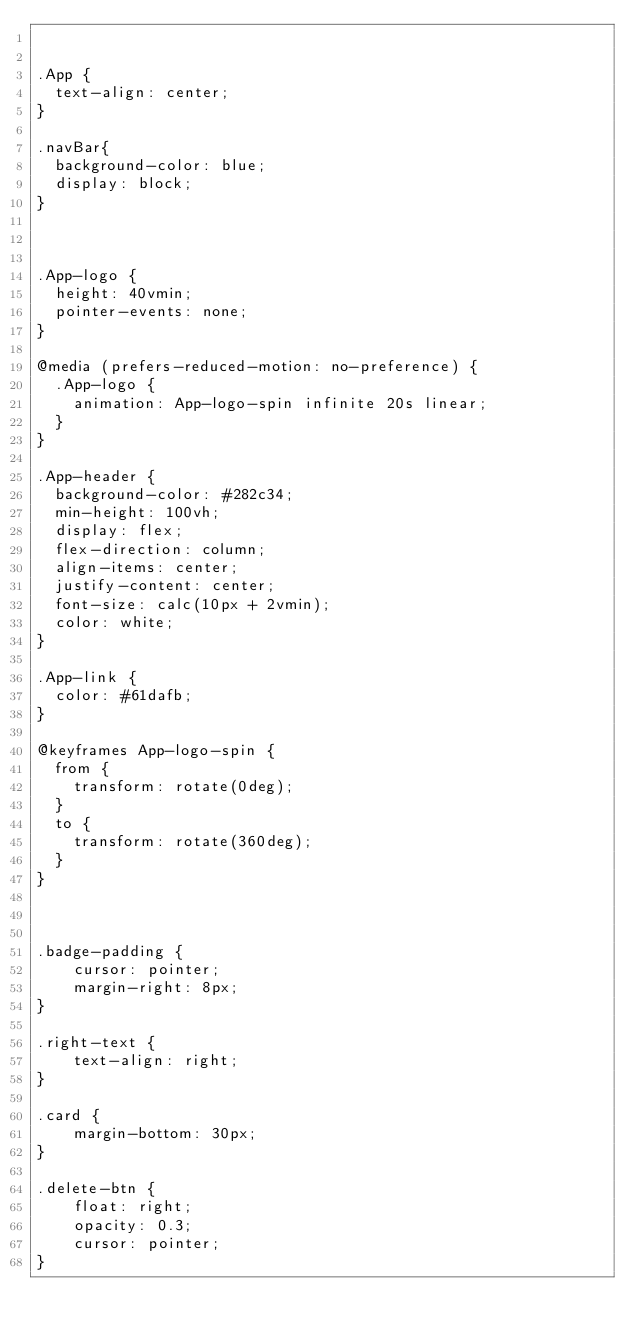Convert code to text. <code><loc_0><loc_0><loc_500><loc_500><_CSS_>

.App {
  text-align: center;
}

.navBar{
  background-color: blue;
  display: block;
}



.App-logo {
  height: 40vmin;
  pointer-events: none;
}

@media (prefers-reduced-motion: no-preference) {
  .App-logo {
    animation: App-logo-spin infinite 20s linear;
  }
}

.App-header {
  background-color: #282c34;
  min-height: 100vh;
  display: flex;
  flex-direction: column;
  align-items: center;
  justify-content: center;
  font-size: calc(10px + 2vmin);
  color: white;
}

.App-link {
  color: #61dafb;
}

@keyframes App-logo-spin {
  from {
    transform: rotate(0deg);
  }
  to {
    transform: rotate(360deg);
  }
}



.badge-padding {
    cursor: pointer;
    margin-right: 8px;
}

.right-text {
    text-align: right;
}

.card {
    margin-bottom: 30px;
}

.delete-btn {
    float: right;
    opacity: 0.3;
    cursor: pointer;
}
</code> 